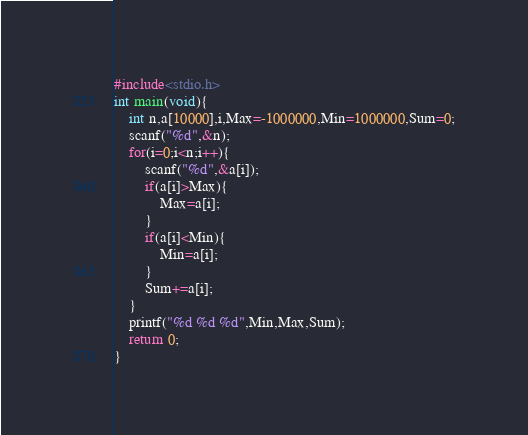<code> <loc_0><loc_0><loc_500><loc_500><_C_>#include<stdio.h>
int main(void){
	int n,a[10000],i,Max=-1000000,Min=1000000,Sum=0;
	scanf("%d",&n);
	for(i=0;i<n;i++){
		scanf("%d",&a[i]);
		if(a[i]>Max){
			Max=a[i];
		}
		if(a[i]<Min){
			Min=a[i];
		}
		Sum+=a[i];
	}
	printf("%d %d %d",Min,Max,Sum);
	return 0;
}</code> 